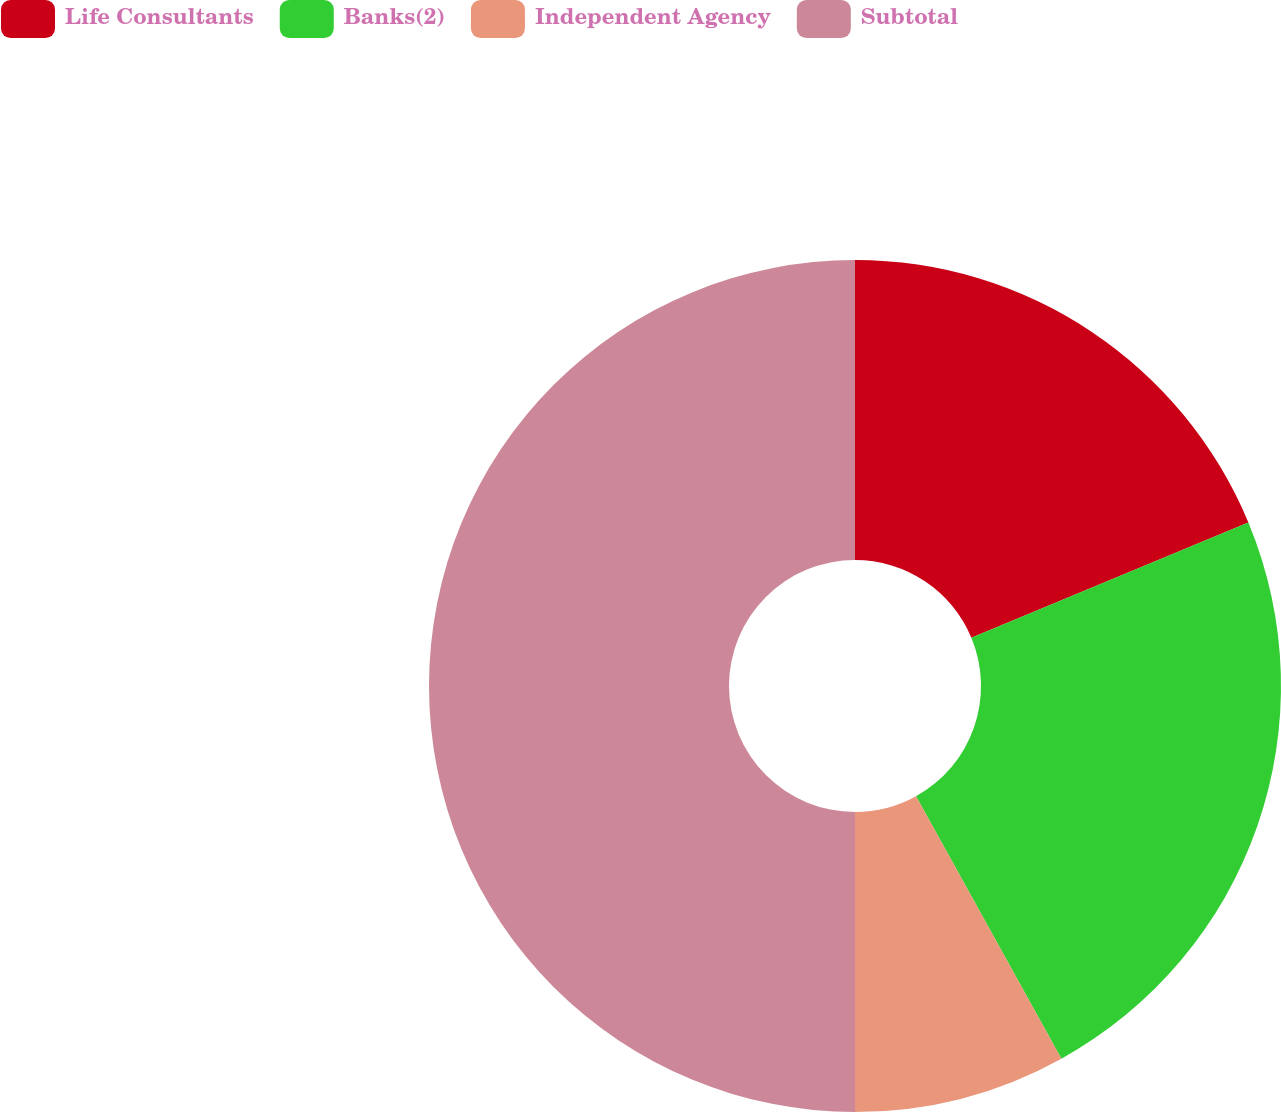Convert chart. <chart><loc_0><loc_0><loc_500><loc_500><pie_chart><fcel>Life Consultants<fcel>Banks(2)<fcel>Independent Agency<fcel>Subtotal<nl><fcel>18.73%<fcel>23.22%<fcel>8.05%<fcel>50.0%<nl></chart> 